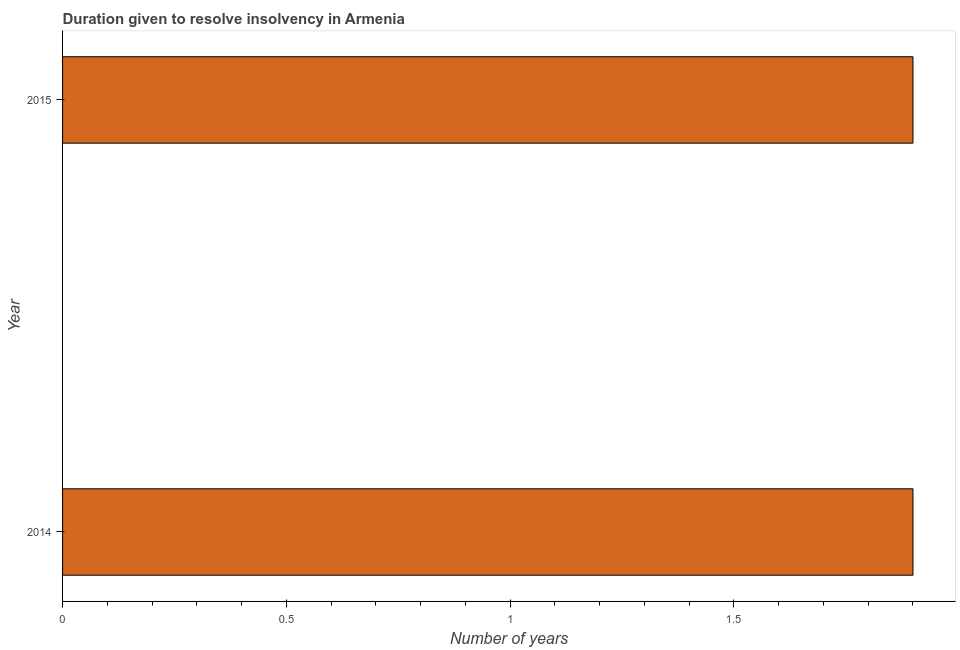What is the title of the graph?
Ensure brevity in your answer.  Duration given to resolve insolvency in Armenia. What is the label or title of the X-axis?
Provide a short and direct response. Number of years. What is the label or title of the Y-axis?
Your answer should be very brief. Year. What is the number of years to resolve insolvency in 2014?
Make the answer very short. 1.9. Across all years, what is the maximum number of years to resolve insolvency?
Ensure brevity in your answer.  1.9. In which year was the number of years to resolve insolvency maximum?
Offer a very short reply. 2014. In which year was the number of years to resolve insolvency minimum?
Make the answer very short. 2014. What is the median number of years to resolve insolvency?
Ensure brevity in your answer.  1.9. In how many years, is the number of years to resolve insolvency greater than 0.9 ?
Make the answer very short. 2. Do a majority of the years between 2015 and 2014 (inclusive) have number of years to resolve insolvency greater than 0.8 ?
Provide a short and direct response. No. What is the ratio of the number of years to resolve insolvency in 2014 to that in 2015?
Provide a succinct answer. 1. Is the number of years to resolve insolvency in 2014 less than that in 2015?
Provide a short and direct response. No. How many bars are there?
Make the answer very short. 2. Are all the bars in the graph horizontal?
Provide a short and direct response. Yes. What is the difference between two consecutive major ticks on the X-axis?
Give a very brief answer. 0.5. What is the difference between the Number of years in 2014 and 2015?
Provide a succinct answer. 0. What is the ratio of the Number of years in 2014 to that in 2015?
Ensure brevity in your answer.  1. 